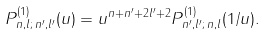<formula> <loc_0><loc_0><loc_500><loc_500>P ^ { ( 1 ) } _ { n , l ; \, n ^ { \prime } , l ^ { \prime } } ( u ) = u ^ { n + n ^ { \prime } + 2 l ^ { \prime } + 2 } P ^ { ( 1 ) } _ { n ^ { \prime } , l ^ { \prime } ; \, n , l } ( 1 / u ) .</formula> 